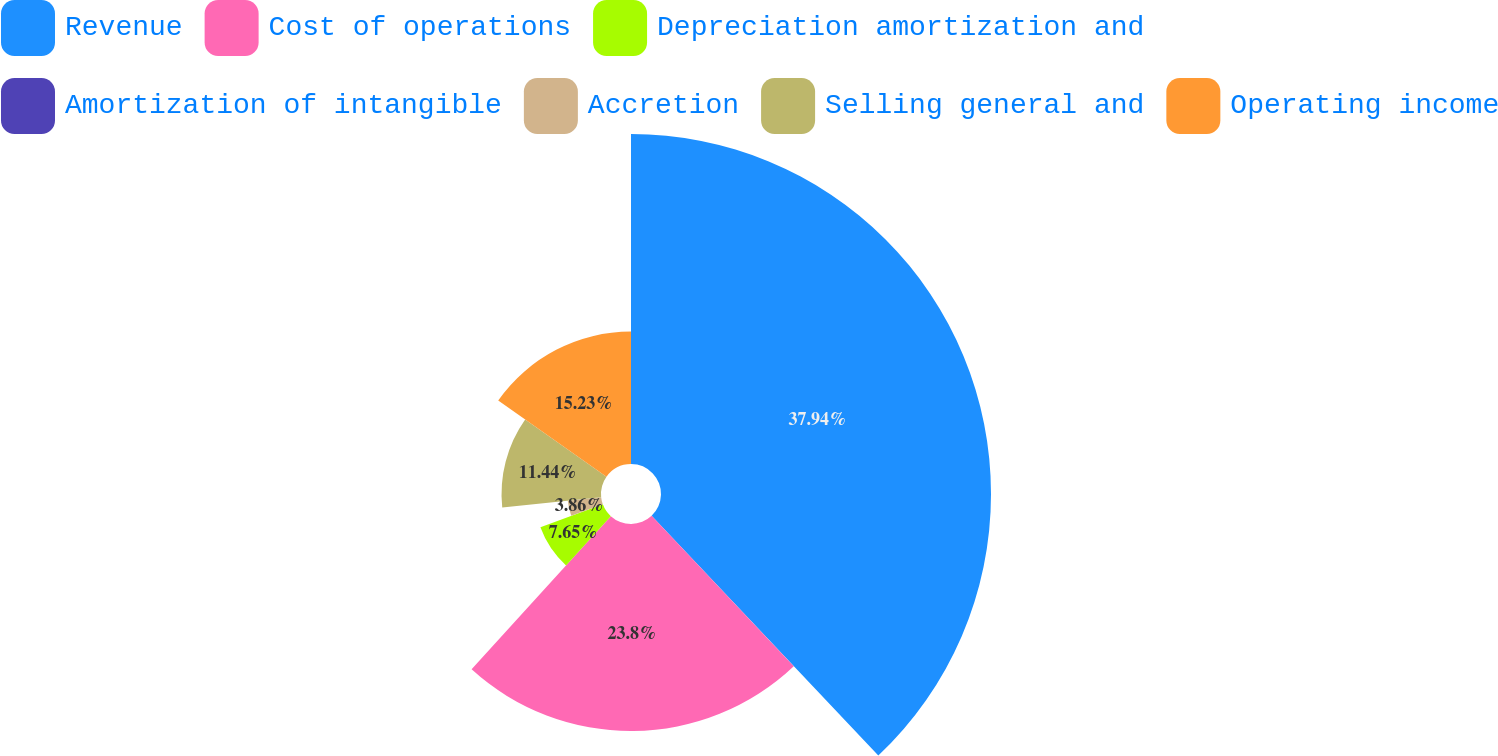<chart> <loc_0><loc_0><loc_500><loc_500><pie_chart><fcel>Revenue<fcel>Cost of operations<fcel>Depreciation amortization and<fcel>Amortization of intangible<fcel>Accretion<fcel>Selling general and<fcel>Operating income<nl><fcel>37.95%<fcel>23.8%<fcel>7.65%<fcel>0.08%<fcel>3.86%<fcel>11.44%<fcel>15.23%<nl></chart> 